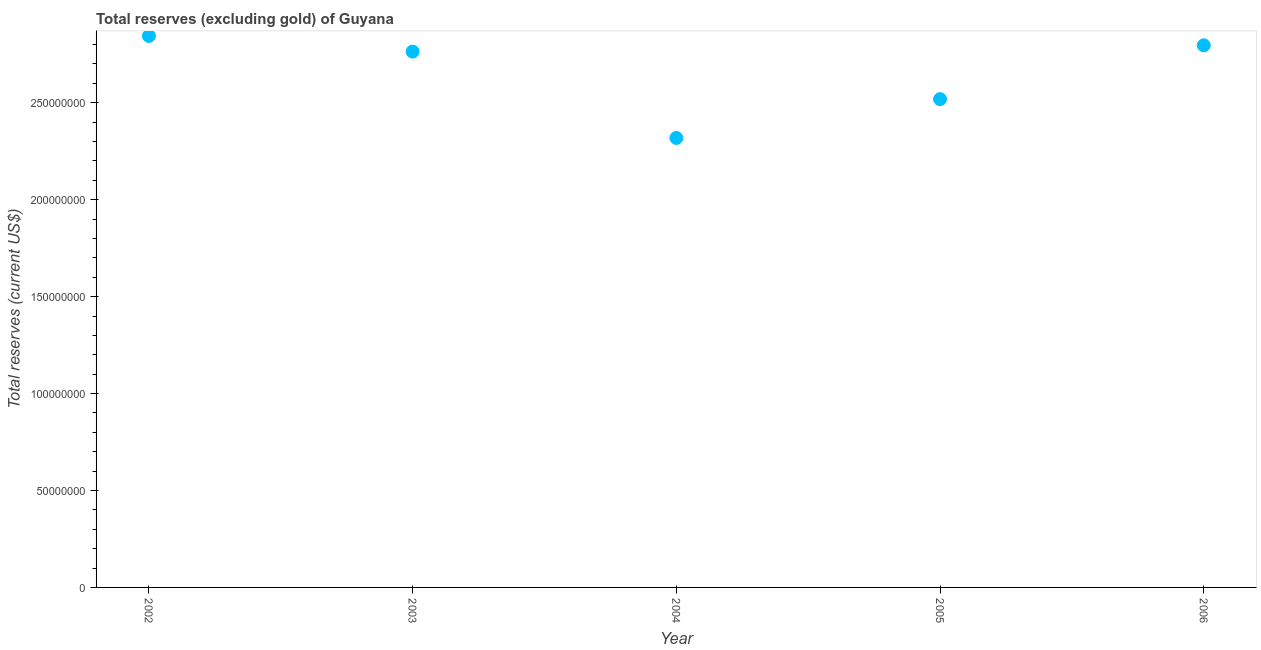What is the total reserves (excluding gold) in 2005?
Make the answer very short. 2.52e+08. Across all years, what is the maximum total reserves (excluding gold)?
Provide a succinct answer. 2.84e+08. Across all years, what is the minimum total reserves (excluding gold)?
Offer a terse response. 2.32e+08. In which year was the total reserves (excluding gold) maximum?
Provide a succinct answer. 2002. What is the sum of the total reserves (excluding gold)?
Ensure brevity in your answer.  1.32e+09. What is the difference between the total reserves (excluding gold) in 2002 and 2005?
Offer a terse response. 3.26e+07. What is the average total reserves (excluding gold) per year?
Keep it short and to the point. 2.65e+08. What is the median total reserves (excluding gold)?
Offer a terse response. 2.76e+08. What is the ratio of the total reserves (excluding gold) in 2003 to that in 2004?
Your answer should be very brief. 1.19. Is the difference between the total reserves (excluding gold) in 2002 and 2006 greater than the difference between any two years?
Your answer should be very brief. No. What is the difference between the highest and the second highest total reserves (excluding gold)?
Keep it short and to the point. 4.84e+06. What is the difference between the highest and the lowest total reserves (excluding gold)?
Provide a short and direct response. 5.26e+07. Does the total reserves (excluding gold) monotonically increase over the years?
Offer a very short reply. No. What is the difference between two consecutive major ticks on the Y-axis?
Provide a short and direct response. 5.00e+07. What is the title of the graph?
Offer a terse response. Total reserves (excluding gold) of Guyana. What is the label or title of the X-axis?
Provide a succinct answer. Year. What is the label or title of the Y-axis?
Keep it short and to the point. Total reserves (current US$). What is the Total reserves (current US$) in 2002?
Provide a short and direct response. 2.84e+08. What is the Total reserves (current US$) in 2003?
Provide a succinct answer. 2.76e+08. What is the Total reserves (current US$) in 2004?
Your response must be concise. 2.32e+08. What is the Total reserves (current US$) in 2005?
Make the answer very short. 2.52e+08. What is the Total reserves (current US$) in 2006?
Ensure brevity in your answer.  2.80e+08. What is the difference between the Total reserves (current US$) in 2002 and 2003?
Provide a succinct answer. 8.09e+06. What is the difference between the Total reserves (current US$) in 2002 and 2004?
Keep it short and to the point. 5.26e+07. What is the difference between the Total reserves (current US$) in 2002 and 2005?
Offer a terse response. 3.26e+07. What is the difference between the Total reserves (current US$) in 2002 and 2006?
Your answer should be very brief. 4.84e+06. What is the difference between the Total reserves (current US$) in 2003 and 2004?
Make the answer very short. 4.45e+07. What is the difference between the Total reserves (current US$) in 2003 and 2005?
Provide a short and direct response. 2.45e+07. What is the difference between the Total reserves (current US$) in 2003 and 2006?
Offer a very short reply. -3.25e+06. What is the difference between the Total reserves (current US$) in 2004 and 2005?
Make the answer very short. -2.00e+07. What is the difference between the Total reserves (current US$) in 2004 and 2006?
Offer a very short reply. -4.78e+07. What is the difference between the Total reserves (current US$) in 2005 and 2006?
Your response must be concise. -2.78e+07. What is the ratio of the Total reserves (current US$) in 2002 to that in 2003?
Your response must be concise. 1.03. What is the ratio of the Total reserves (current US$) in 2002 to that in 2004?
Offer a very short reply. 1.23. What is the ratio of the Total reserves (current US$) in 2002 to that in 2005?
Ensure brevity in your answer.  1.13. What is the ratio of the Total reserves (current US$) in 2002 to that in 2006?
Provide a short and direct response. 1.02. What is the ratio of the Total reserves (current US$) in 2003 to that in 2004?
Your answer should be compact. 1.19. What is the ratio of the Total reserves (current US$) in 2003 to that in 2005?
Give a very brief answer. 1.1. What is the ratio of the Total reserves (current US$) in 2003 to that in 2006?
Provide a short and direct response. 0.99. What is the ratio of the Total reserves (current US$) in 2004 to that in 2005?
Your answer should be compact. 0.92. What is the ratio of the Total reserves (current US$) in 2004 to that in 2006?
Offer a terse response. 0.83. What is the ratio of the Total reserves (current US$) in 2005 to that in 2006?
Ensure brevity in your answer.  0.9. 